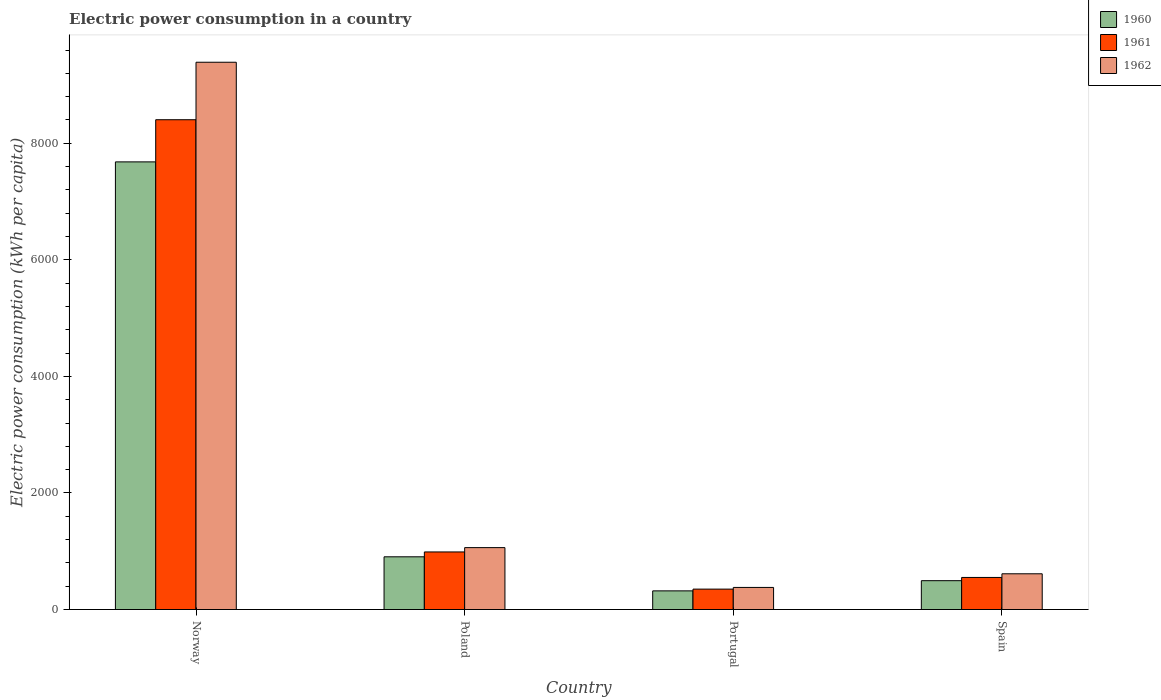How many different coloured bars are there?
Offer a terse response. 3. Are the number of bars on each tick of the X-axis equal?
Make the answer very short. Yes. How many bars are there on the 1st tick from the left?
Provide a succinct answer. 3. How many bars are there on the 2nd tick from the right?
Ensure brevity in your answer.  3. What is the electric power consumption in in 1961 in Spain?
Your response must be concise. 550.44. Across all countries, what is the maximum electric power consumption in in 1961?
Ensure brevity in your answer.  8404.62. Across all countries, what is the minimum electric power consumption in in 1962?
Offer a very short reply. 379.14. In which country was the electric power consumption in in 1962 maximum?
Your answer should be very brief. Norway. In which country was the electric power consumption in in 1960 minimum?
Your answer should be compact. Portugal. What is the total electric power consumption in in 1960 in the graph?
Your response must be concise. 9400.67. What is the difference between the electric power consumption in in 1960 in Norway and that in Spain?
Your answer should be very brief. 7186.34. What is the difference between the electric power consumption in in 1962 in Poland and the electric power consumption in in 1960 in Norway?
Give a very brief answer. -6618.96. What is the average electric power consumption in in 1960 per country?
Your answer should be compact. 2350.17. What is the difference between the electric power consumption in of/in 1960 and electric power consumption in of/in 1961 in Portugal?
Ensure brevity in your answer.  -30.02. In how many countries, is the electric power consumption in in 1961 greater than 400 kWh per capita?
Offer a very short reply. 3. What is the ratio of the electric power consumption in in 1961 in Poland to that in Spain?
Make the answer very short. 1.79. Is the electric power consumption in in 1962 in Portugal less than that in Spain?
Offer a very short reply. Yes. What is the difference between the highest and the second highest electric power consumption in in 1962?
Ensure brevity in your answer.  448.93. What is the difference between the highest and the lowest electric power consumption in in 1962?
Your answer should be very brief. 9011.84. In how many countries, is the electric power consumption in in 1960 greater than the average electric power consumption in in 1960 taken over all countries?
Provide a short and direct response. 1. What does the 2nd bar from the right in Poland represents?
Your answer should be compact. 1961. Is it the case that in every country, the sum of the electric power consumption in in 1960 and electric power consumption in in 1962 is greater than the electric power consumption in in 1961?
Make the answer very short. Yes. How many bars are there?
Provide a succinct answer. 12. Are all the bars in the graph horizontal?
Offer a terse response. No. How many countries are there in the graph?
Your answer should be compact. 4. What is the difference between two consecutive major ticks on the Y-axis?
Your answer should be compact. 2000. Are the values on the major ticks of Y-axis written in scientific E-notation?
Ensure brevity in your answer.  No. Does the graph contain any zero values?
Offer a terse response. No. What is the title of the graph?
Provide a short and direct response. Electric power consumption in a country. Does "1973" appear as one of the legend labels in the graph?
Provide a succinct answer. No. What is the label or title of the Y-axis?
Your response must be concise. Electric power consumption (kWh per capita). What is the Electric power consumption (kWh per capita) in 1960 in Norway?
Ensure brevity in your answer.  7681.14. What is the Electric power consumption (kWh per capita) in 1961 in Norway?
Offer a terse response. 8404.62. What is the Electric power consumption (kWh per capita) of 1962 in Norway?
Offer a very short reply. 9390.98. What is the Electric power consumption (kWh per capita) in 1960 in Poland?
Give a very brief answer. 904.57. What is the Electric power consumption (kWh per capita) in 1961 in Poland?
Your answer should be compact. 987.92. What is the Electric power consumption (kWh per capita) in 1962 in Poland?
Provide a short and direct response. 1062.18. What is the Electric power consumption (kWh per capita) in 1960 in Portugal?
Provide a succinct answer. 320.17. What is the Electric power consumption (kWh per capita) in 1961 in Portugal?
Your answer should be compact. 350.19. What is the Electric power consumption (kWh per capita) of 1962 in Portugal?
Provide a short and direct response. 379.14. What is the Electric power consumption (kWh per capita) of 1960 in Spain?
Your answer should be compact. 494.8. What is the Electric power consumption (kWh per capita) of 1961 in Spain?
Offer a very short reply. 550.44. What is the Electric power consumption (kWh per capita) in 1962 in Spain?
Provide a succinct answer. 613.25. Across all countries, what is the maximum Electric power consumption (kWh per capita) in 1960?
Make the answer very short. 7681.14. Across all countries, what is the maximum Electric power consumption (kWh per capita) of 1961?
Your response must be concise. 8404.62. Across all countries, what is the maximum Electric power consumption (kWh per capita) of 1962?
Provide a succinct answer. 9390.98. Across all countries, what is the minimum Electric power consumption (kWh per capita) in 1960?
Make the answer very short. 320.17. Across all countries, what is the minimum Electric power consumption (kWh per capita) of 1961?
Provide a succinct answer. 350.19. Across all countries, what is the minimum Electric power consumption (kWh per capita) of 1962?
Make the answer very short. 379.14. What is the total Electric power consumption (kWh per capita) of 1960 in the graph?
Your answer should be compact. 9400.67. What is the total Electric power consumption (kWh per capita) in 1961 in the graph?
Your answer should be compact. 1.03e+04. What is the total Electric power consumption (kWh per capita) of 1962 in the graph?
Your response must be concise. 1.14e+04. What is the difference between the Electric power consumption (kWh per capita) in 1960 in Norway and that in Poland?
Offer a very short reply. 6776.58. What is the difference between the Electric power consumption (kWh per capita) of 1961 in Norway and that in Poland?
Offer a terse response. 7416.7. What is the difference between the Electric power consumption (kWh per capita) of 1962 in Norway and that in Poland?
Keep it short and to the point. 8328.8. What is the difference between the Electric power consumption (kWh per capita) in 1960 in Norway and that in Portugal?
Ensure brevity in your answer.  7360.97. What is the difference between the Electric power consumption (kWh per capita) of 1961 in Norway and that in Portugal?
Your response must be concise. 8054.43. What is the difference between the Electric power consumption (kWh per capita) in 1962 in Norway and that in Portugal?
Offer a very short reply. 9011.84. What is the difference between the Electric power consumption (kWh per capita) in 1960 in Norway and that in Spain?
Provide a short and direct response. 7186.34. What is the difference between the Electric power consumption (kWh per capita) of 1961 in Norway and that in Spain?
Your answer should be compact. 7854.18. What is the difference between the Electric power consumption (kWh per capita) in 1962 in Norway and that in Spain?
Ensure brevity in your answer.  8777.73. What is the difference between the Electric power consumption (kWh per capita) of 1960 in Poland and that in Portugal?
Your response must be concise. 584.39. What is the difference between the Electric power consumption (kWh per capita) of 1961 in Poland and that in Portugal?
Your answer should be compact. 637.72. What is the difference between the Electric power consumption (kWh per capita) of 1962 in Poland and that in Portugal?
Keep it short and to the point. 683.03. What is the difference between the Electric power consumption (kWh per capita) of 1960 in Poland and that in Spain?
Give a very brief answer. 409.77. What is the difference between the Electric power consumption (kWh per capita) of 1961 in Poland and that in Spain?
Give a very brief answer. 437.48. What is the difference between the Electric power consumption (kWh per capita) in 1962 in Poland and that in Spain?
Your answer should be very brief. 448.93. What is the difference between the Electric power consumption (kWh per capita) in 1960 in Portugal and that in Spain?
Provide a succinct answer. -174.62. What is the difference between the Electric power consumption (kWh per capita) in 1961 in Portugal and that in Spain?
Keep it short and to the point. -200.24. What is the difference between the Electric power consumption (kWh per capita) of 1962 in Portugal and that in Spain?
Offer a terse response. -234.11. What is the difference between the Electric power consumption (kWh per capita) of 1960 in Norway and the Electric power consumption (kWh per capita) of 1961 in Poland?
Provide a short and direct response. 6693.22. What is the difference between the Electric power consumption (kWh per capita) of 1960 in Norway and the Electric power consumption (kWh per capita) of 1962 in Poland?
Provide a short and direct response. 6618.96. What is the difference between the Electric power consumption (kWh per capita) of 1961 in Norway and the Electric power consumption (kWh per capita) of 1962 in Poland?
Give a very brief answer. 7342.44. What is the difference between the Electric power consumption (kWh per capita) in 1960 in Norway and the Electric power consumption (kWh per capita) in 1961 in Portugal?
Ensure brevity in your answer.  7330.95. What is the difference between the Electric power consumption (kWh per capita) in 1960 in Norway and the Electric power consumption (kWh per capita) in 1962 in Portugal?
Provide a short and direct response. 7302. What is the difference between the Electric power consumption (kWh per capita) of 1961 in Norway and the Electric power consumption (kWh per capita) of 1962 in Portugal?
Give a very brief answer. 8025.48. What is the difference between the Electric power consumption (kWh per capita) of 1960 in Norway and the Electric power consumption (kWh per capita) of 1961 in Spain?
Your answer should be very brief. 7130.7. What is the difference between the Electric power consumption (kWh per capita) in 1960 in Norway and the Electric power consumption (kWh per capita) in 1962 in Spain?
Keep it short and to the point. 7067.89. What is the difference between the Electric power consumption (kWh per capita) in 1961 in Norway and the Electric power consumption (kWh per capita) in 1962 in Spain?
Your answer should be compact. 7791.37. What is the difference between the Electric power consumption (kWh per capita) in 1960 in Poland and the Electric power consumption (kWh per capita) in 1961 in Portugal?
Provide a short and direct response. 554.37. What is the difference between the Electric power consumption (kWh per capita) in 1960 in Poland and the Electric power consumption (kWh per capita) in 1962 in Portugal?
Make the answer very short. 525.42. What is the difference between the Electric power consumption (kWh per capita) in 1961 in Poland and the Electric power consumption (kWh per capita) in 1962 in Portugal?
Provide a short and direct response. 608.78. What is the difference between the Electric power consumption (kWh per capita) in 1960 in Poland and the Electric power consumption (kWh per capita) in 1961 in Spain?
Provide a short and direct response. 354.13. What is the difference between the Electric power consumption (kWh per capita) in 1960 in Poland and the Electric power consumption (kWh per capita) in 1962 in Spain?
Ensure brevity in your answer.  291.32. What is the difference between the Electric power consumption (kWh per capita) in 1961 in Poland and the Electric power consumption (kWh per capita) in 1962 in Spain?
Your response must be concise. 374.67. What is the difference between the Electric power consumption (kWh per capita) in 1960 in Portugal and the Electric power consumption (kWh per capita) in 1961 in Spain?
Offer a terse response. -230.26. What is the difference between the Electric power consumption (kWh per capita) in 1960 in Portugal and the Electric power consumption (kWh per capita) in 1962 in Spain?
Make the answer very short. -293.07. What is the difference between the Electric power consumption (kWh per capita) of 1961 in Portugal and the Electric power consumption (kWh per capita) of 1962 in Spain?
Ensure brevity in your answer.  -263.05. What is the average Electric power consumption (kWh per capita) in 1960 per country?
Ensure brevity in your answer.  2350.17. What is the average Electric power consumption (kWh per capita) in 1961 per country?
Your answer should be very brief. 2573.29. What is the average Electric power consumption (kWh per capita) in 1962 per country?
Offer a terse response. 2861.39. What is the difference between the Electric power consumption (kWh per capita) in 1960 and Electric power consumption (kWh per capita) in 1961 in Norway?
Your response must be concise. -723.48. What is the difference between the Electric power consumption (kWh per capita) in 1960 and Electric power consumption (kWh per capita) in 1962 in Norway?
Your answer should be very brief. -1709.84. What is the difference between the Electric power consumption (kWh per capita) of 1961 and Electric power consumption (kWh per capita) of 1962 in Norway?
Your response must be concise. -986.36. What is the difference between the Electric power consumption (kWh per capita) in 1960 and Electric power consumption (kWh per capita) in 1961 in Poland?
Provide a succinct answer. -83.35. What is the difference between the Electric power consumption (kWh per capita) of 1960 and Electric power consumption (kWh per capita) of 1962 in Poland?
Your answer should be compact. -157.61. What is the difference between the Electric power consumption (kWh per capita) in 1961 and Electric power consumption (kWh per capita) in 1962 in Poland?
Your answer should be very brief. -74.26. What is the difference between the Electric power consumption (kWh per capita) in 1960 and Electric power consumption (kWh per capita) in 1961 in Portugal?
Keep it short and to the point. -30.02. What is the difference between the Electric power consumption (kWh per capita) of 1960 and Electric power consumption (kWh per capita) of 1962 in Portugal?
Keep it short and to the point. -58.97. What is the difference between the Electric power consumption (kWh per capita) of 1961 and Electric power consumption (kWh per capita) of 1962 in Portugal?
Ensure brevity in your answer.  -28.95. What is the difference between the Electric power consumption (kWh per capita) in 1960 and Electric power consumption (kWh per capita) in 1961 in Spain?
Make the answer very short. -55.64. What is the difference between the Electric power consumption (kWh per capita) of 1960 and Electric power consumption (kWh per capita) of 1962 in Spain?
Provide a succinct answer. -118.45. What is the difference between the Electric power consumption (kWh per capita) in 1961 and Electric power consumption (kWh per capita) in 1962 in Spain?
Make the answer very short. -62.81. What is the ratio of the Electric power consumption (kWh per capita) in 1960 in Norway to that in Poland?
Your answer should be very brief. 8.49. What is the ratio of the Electric power consumption (kWh per capita) in 1961 in Norway to that in Poland?
Your answer should be compact. 8.51. What is the ratio of the Electric power consumption (kWh per capita) of 1962 in Norway to that in Poland?
Keep it short and to the point. 8.84. What is the ratio of the Electric power consumption (kWh per capita) of 1960 in Norway to that in Portugal?
Provide a succinct answer. 23.99. What is the ratio of the Electric power consumption (kWh per capita) in 1961 in Norway to that in Portugal?
Keep it short and to the point. 24. What is the ratio of the Electric power consumption (kWh per capita) of 1962 in Norway to that in Portugal?
Offer a terse response. 24.77. What is the ratio of the Electric power consumption (kWh per capita) in 1960 in Norway to that in Spain?
Your response must be concise. 15.52. What is the ratio of the Electric power consumption (kWh per capita) in 1961 in Norway to that in Spain?
Ensure brevity in your answer.  15.27. What is the ratio of the Electric power consumption (kWh per capita) in 1962 in Norway to that in Spain?
Your answer should be compact. 15.31. What is the ratio of the Electric power consumption (kWh per capita) of 1960 in Poland to that in Portugal?
Offer a terse response. 2.83. What is the ratio of the Electric power consumption (kWh per capita) in 1961 in Poland to that in Portugal?
Your response must be concise. 2.82. What is the ratio of the Electric power consumption (kWh per capita) in 1962 in Poland to that in Portugal?
Keep it short and to the point. 2.8. What is the ratio of the Electric power consumption (kWh per capita) of 1960 in Poland to that in Spain?
Your answer should be very brief. 1.83. What is the ratio of the Electric power consumption (kWh per capita) of 1961 in Poland to that in Spain?
Provide a succinct answer. 1.79. What is the ratio of the Electric power consumption (kWh per capita) of 1962 in Poland to that in Spain?
Keep it short and to the point. 1.73. What is the ratio of the Electric power consumption (kWh per capita) in 1960 in Portugal to that in Spain?
Provide a short and direct response. 0.65. What is the ratio of the Electric power consumption (kWh per capita) in 1961 in Portugal to that in Spain?
Provide a succinct answer. 0.64. What is the ratio of the Electric power consumption (kWh per capita) of 1962 in Portugal to that in Spain?
Offer a very short reply. 0.62. What is the difference between the highest and the second highest Electric power consumption (kWh per capita) in 1960?
Your answer should be very brief. 6776.58. What is the difference between the highest and the second highest Electric power consumption (kWh per capita) of 1961?
Offer a terse response. 7416.7. What is the difference between the highest and the second highest Electric power consumption (kWh per capita) in 1962?
Provide a succinct answer. 8328.8. What is the difference between the highest and the lowest Electric power consumption (kWh per capita) in 1960?
Provide a succinct answer. 7360.97. What is the difference between the highest and the lowest Electric power consumption (kWh per capita) of 1961?
Make the answer very short. 8054.43. What is the difference between the highest and the lowest Electric power consumption (kWh per capita) of 1962?
Ensure brevity in your answer.  9011.84. 